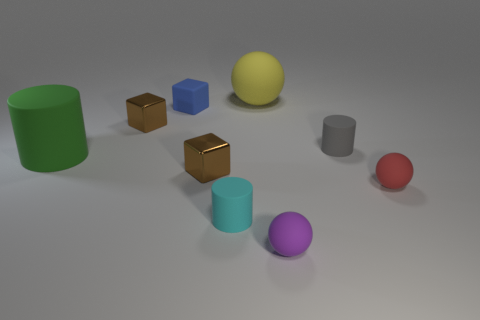Add 1 small purple balls. How many objects exist? 10 Subtract all cylinders. How many objects are left? 6 Subtract 0 gray blocks. How many objects are left? 9 Subtract all large green rubber cylinders. Subtract all tiny red rubber balls. How many objects are left? 7 Add 7 gray cylinders. How many gray cylinders are left? 8 Add 6 tiny cylinders. How many tiny cylinders exist? 8 